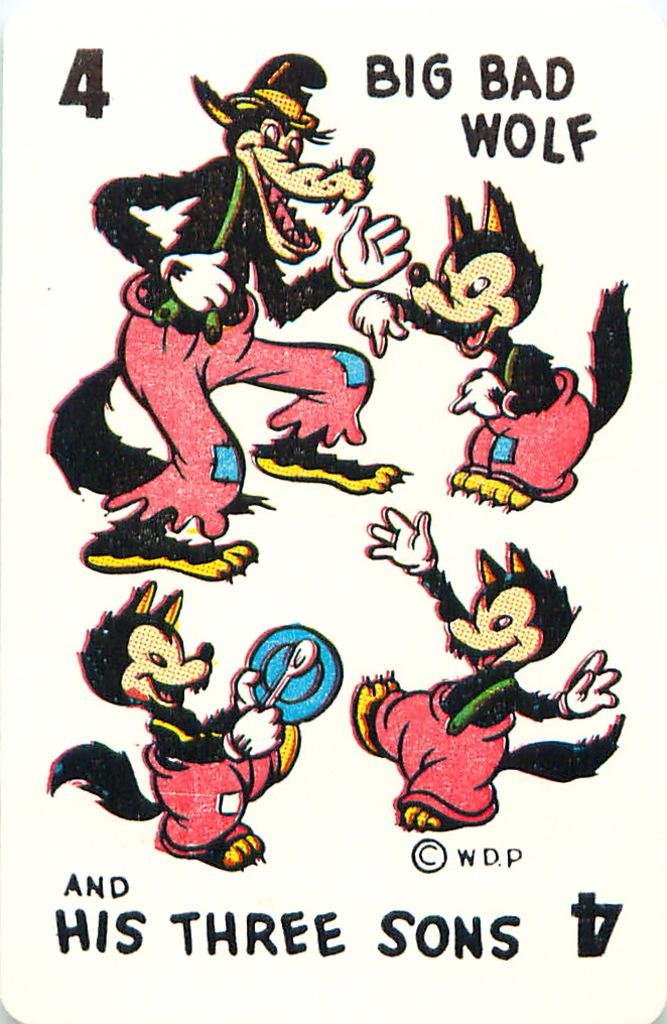What type of animals are depicted in the image? There are four wolf cartoon images in the image. What is the relationship between the wolves mentioned in the text? The text says "big bad wolf and his three sons," so the relationship is that the big bad wolf is the father of the three other wolves. What type of owl can be seen in the image? There is no owl present in the image; it features four wolf cartoon images and the text "big bad wolf and his three sons." 